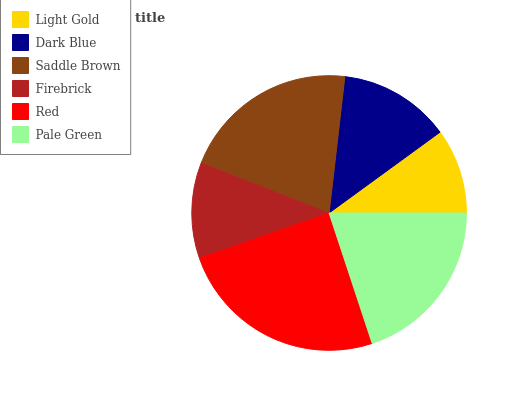Is Light Gold the minimum?
Answer yes or no. Yes. Is Red the maximum?
Answer yes or no. Yes. Is Dark Blue the minimum?
Answer yes or no. No. Is Dark Blue the maximum?
Answer yes or no. No. Is Dark Blue greater than Light Gold?
Answer yes or no. Yes. Is Light Gold less than Dark Blue?
Answer yes or no. Yes. Is Light Gold greater than Dark Blue?
Answer yes or no. No. Is Dark Blue less than Light Gold?
Answer yes or no. No. Is Pale Green the high median?
Answer yes or no. Yes. Is Dark Blue the low median?
Answer yes or no. Yes. Is Red the high median?
Answer yes or no. No. Is Light Gold the low median?
Answer yes or no. No. 